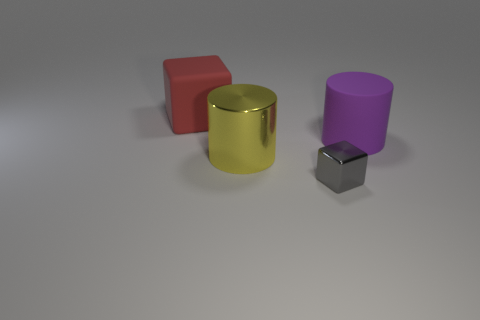Add 2 red matte cubes. How many objects exist? 6 Subtract all metallic objects. Subtract all rubber things. How many objects are left? 0 Add 1 big metallic objects. How many big metallic objects are left? 2 Add 3 tiny gray things. How many tiny gray things exist? 4 Subtract 0 green cylinders. How many objects are left? 4 